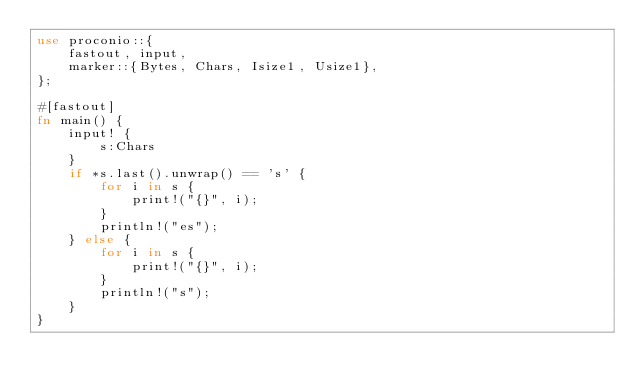<code> <loc_0><loc_0><loc_500><loc_500><_Rust_>use proconio::{
    fastout, input,
    marker::{Bytes, Chars, Isize1, Usize1},
};

#[fastout]
fn main() {
    input! {
        s:Chars
    }
    if *s.last().unwrap() == 's' {
        for i in s {
            print!("{}", i);
        }
        println!("es");
    } else {
        for i in s {
            print!("{}", i);
        }
        println!("s");
    }
}
</code> 